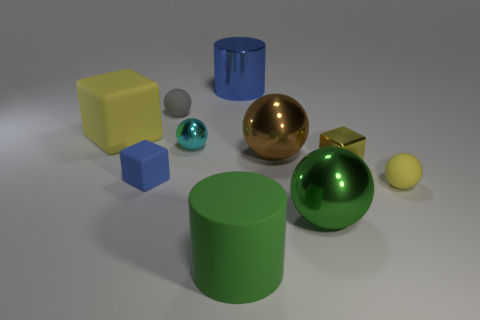There is a cyan sphere that is the same size as the blue matte object; what is its material?
Ensure brevity in your answer.  Metal. Are there any cyan objects that have the same size as the gray rubber object?
Your answer should be very brief. Yes. Do the rubber sphere that is on the left side of the green cylinder and the rubber sphere that is to the right of the green rubber cylinder have the same color?
Your answer should be compact. No. What number of rubber things are big blue things or tiny cyan spheres?
Offer a terse response. 0. What number of big green cylinders are to the right of the large shiny ball that is in front of the yellow cube on the right side of the big blue metallic object?
Keep it short and to the point. 0. What is the size of the cylinder that is made of the same material as the brown thing?
Make the answer very short. Large. What number of cubes are the same color as the metal cylinder?
Your response must be concise. 1. There is a rubber block that is in front of the brown metal thing; is its size the same as the large blue cylinder?
Provide a short and direct response. No. What color is the metal sphere that is both right of the big green rubber thing and behind the large green sphere?
Your answer should be very brief. Brown. How many objects are brown cylinders or small blocks on the right side of the large blue cylinder?
Make the answer very short. 1. 